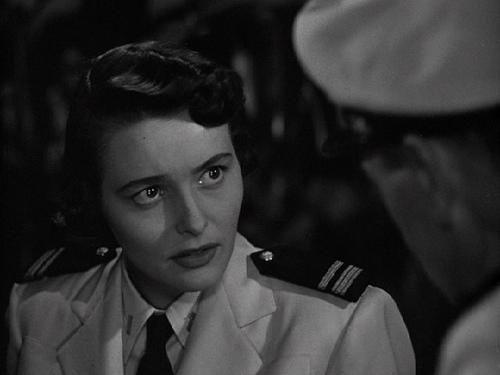Is this a bad guy?
Quick response, please. No. Does this photo look like it was from classic movie?
Short answer required. Yes. How old is the person?
Answer briefly. 35. Which article of clothing the woman in the picture is wearing is traditionally meant for men?
Keep it brief. Uniform. Is she smiling?
Be succinct. No. In which decade do you think this photo was taken?
Short answer required. 50s. 